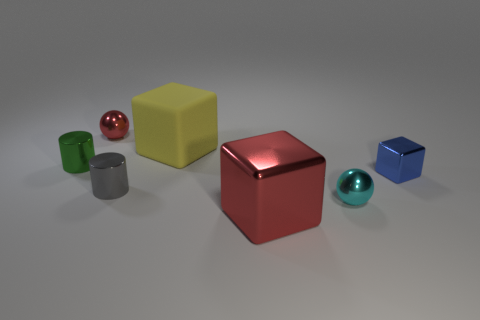Subtract all shiny blocks. How many blocks are left? 1 Add 2 large red things. How many objects exist? 9 Subtract all cylinders. How many objects are left? 5 Add 4 large red things. How many large red things exist? 5 Subtract 0 gray balls. How many objects are left? 7 Subtract all red shiny cylinders. Subtract all cyan shiny things. How many objects are left? 6 Add 1 gray cylinders. How many gray cylinders are left? 2 